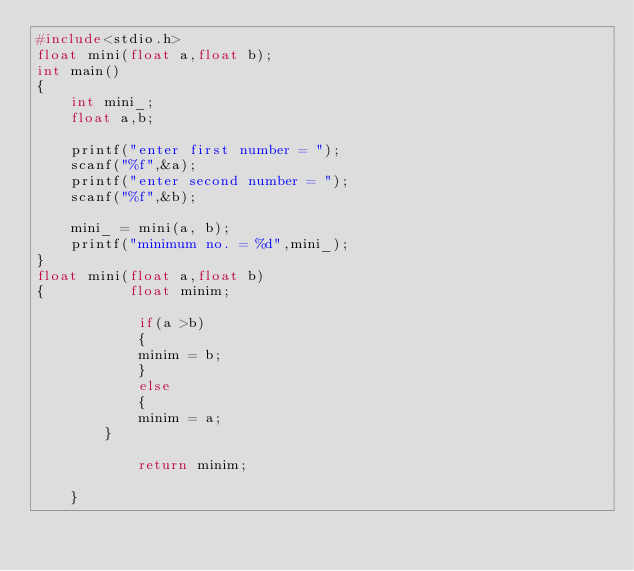<code> <loc_0><loc_0><loc_500><loc_500><_C++_>#include<stdio.h>
float mini(float a,float b);
int main()
{  
	int mini_;
	float a,b;
	
	printf("enter first number = ");
	scanf("%f",&a);
	printf("enter second number = ");
	scanf("%f",&b);
	
	mini_ = mini(a, b);
	printf("minimum no. = %d",mini_);
}
float mini(float a,float b)
{          float minim;
	
			if(a >b)
			{	
			minim = b;
			}
			else
			{
			minim = a;
		}
			
			return minim;
			
	}
	
	




</code> 